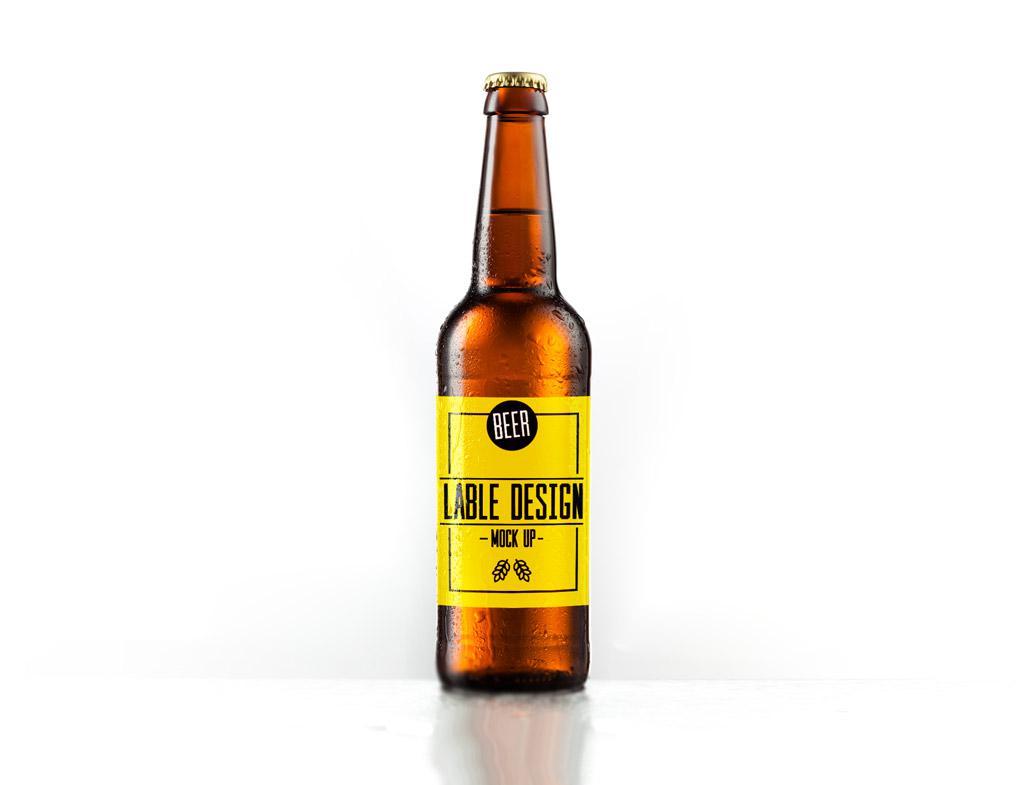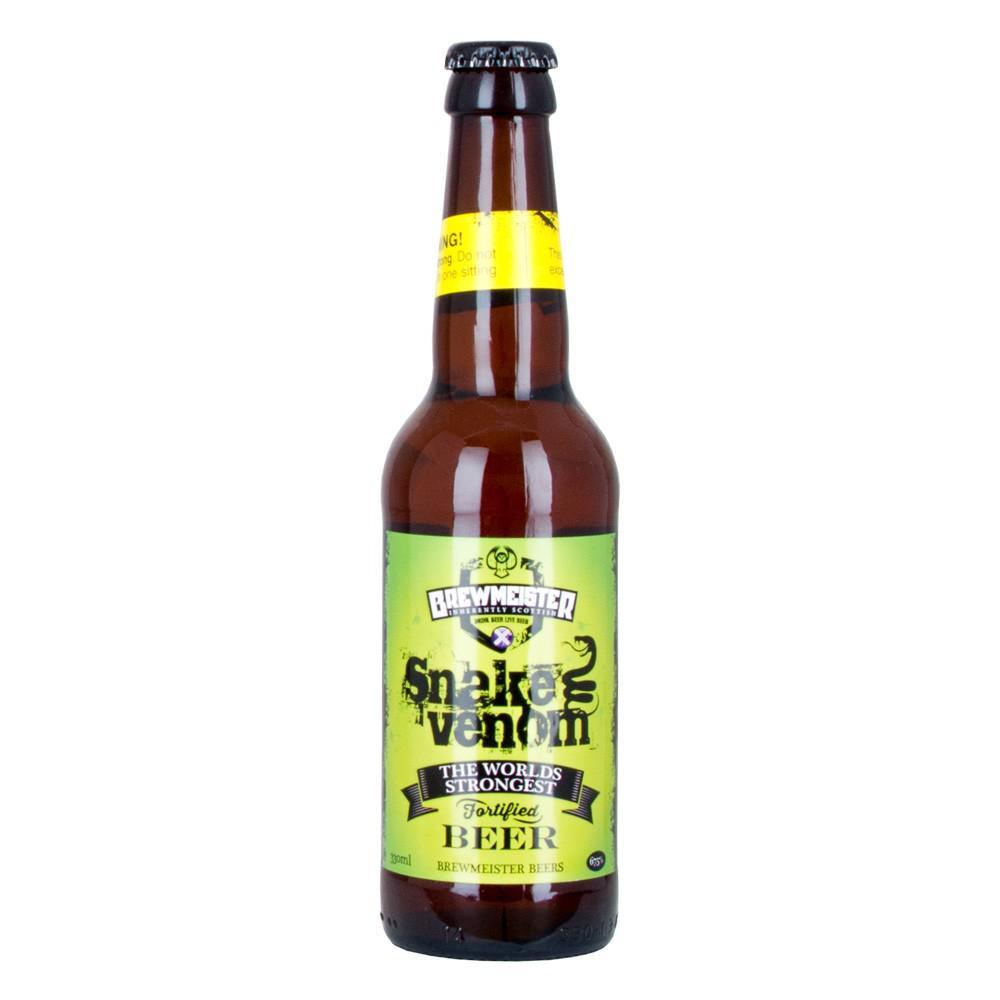The first image is the image on the left, the second image is the image on the right. Evaluate the accuracy of this statement regarding the images: "At least two beer bottles have labels on body and neck of the bottle, and exactly one bottle has just a body label.". Is it true? Answer yes or no. No. The first image is the image on the left, the second image is the image on the right. For the images displayed, is the sentence "there are at least two bottles in the image on the left" factually correct? Answer yes or no. No. The first image is the image on the left, the second image is the image on the right. Assess this claim about the two images: "There are two glass beer bottles". Correct or not? Answer yes or no. Yes. The first image is the image on the left, the second image is the image on the right. Given the left and right images, does the statement "There are no less than three beer bottles" hold true? Answer yes or no. No. 